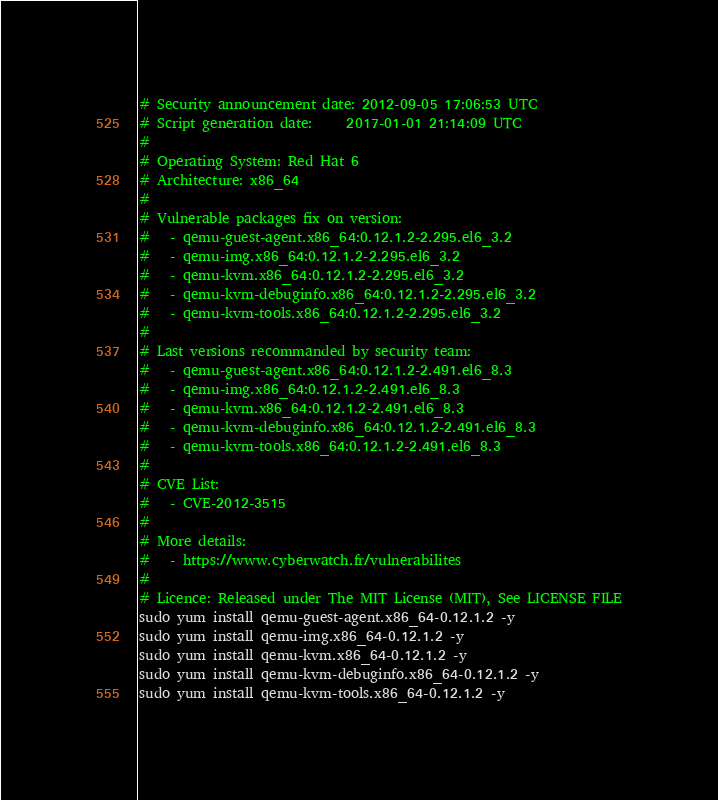Convert code to text. <code><loc_0><loc_0><loc_500><loc_500><_Bash_># Security announcement date: 2012-09-05 17:06:53 UTC
# Script generation date:     2017-01-01 21:14:09 UTC
#
# Operating System: Red Hat 6
# Architecture: x86_64
#
# Vulnerable packages fix on version:
#   - qemu-guest-agent.x86_64:0.12.1.2-2.295.el6_3.2
#   - qemu-img.x86_64:0.12.1.2-2.295.el6_3.2
#   - qemu-kvm.x86_64:0.12.1.2-2.295.el6_3.2
#   - qemu-kvm-debuginfo.x86_64:0.12.1.2-2.295.el6_3.2
#   - qemu-kvm-tools.x86_64:0.12.1.2-2.295.el6_3.2
#
# Last versions recommanded by security team:
#   - qemu-guest-agent.x86_64:0.12.1.2-2.491.el6_8.3
#   - qemu-img.x86_64:0.12.1.2-2.491.el6_8.3
#   - qemu-kvm.x86_64:0.12.1.2-2.491.el6_8.3
#   - qemu-kvm-debuginfo.x86_64:0.12.1.2-2.491.el6_8.3
#   - qemu-kvm-tools.x86_64:0.12.1.2-2.491.el6_8.3
#
# CVE List:
#   - CVE-2012-3515
#
# More details:
#   - https://www.cyberwatch.fr/vulnerabilites
#
# Licence: Released under The MIT License (MIT), See LICENSE FILE
sudo yum install qemu-guest-agent.x86_64-0.12.1.2 -y 
sudo yum install qemu-img.x86_64-0.12.1.2 -y 
sudo yum install qemu-kvm.x86_64-0.12.1.2 -y 
sudo yum install qemu-kvm-debuginfo.x86_64-0.12.1.2 -y 
sudo yum install qemu-kvm-tools.x86_64-0.12.1.2 -y 
</code> 